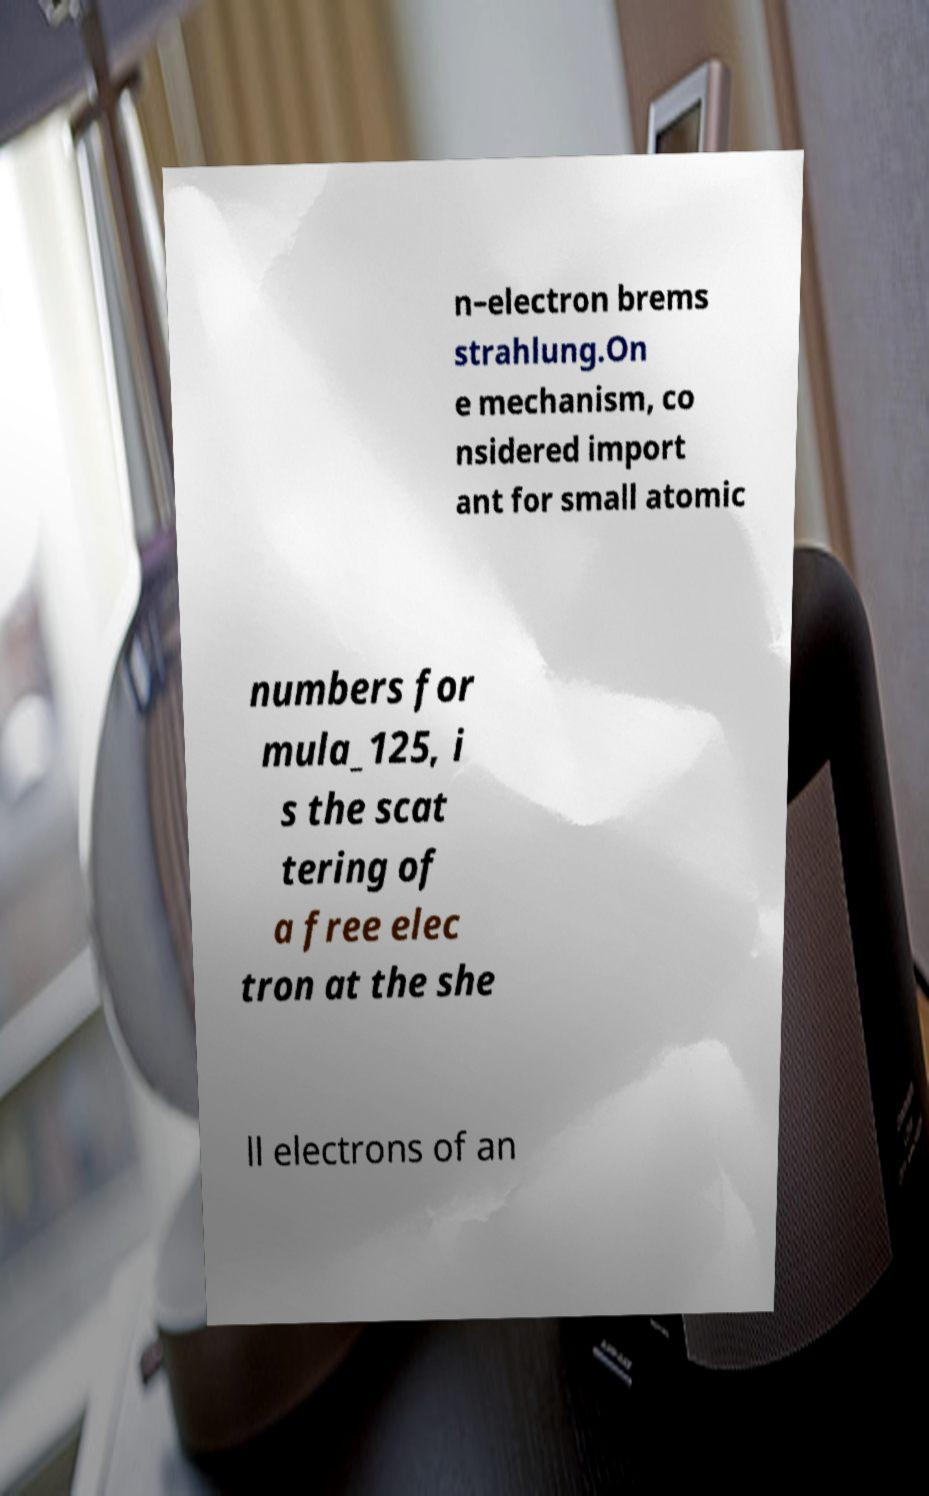There's text embedded in this image that I need extracted. Can you transcribe it verbatim? n–electron brems strahlung.On e mechanism, co nsidered import ant for small atomic numbers for mula_125, i s the scat tering of a free elec tron at the she ll electrons of an 